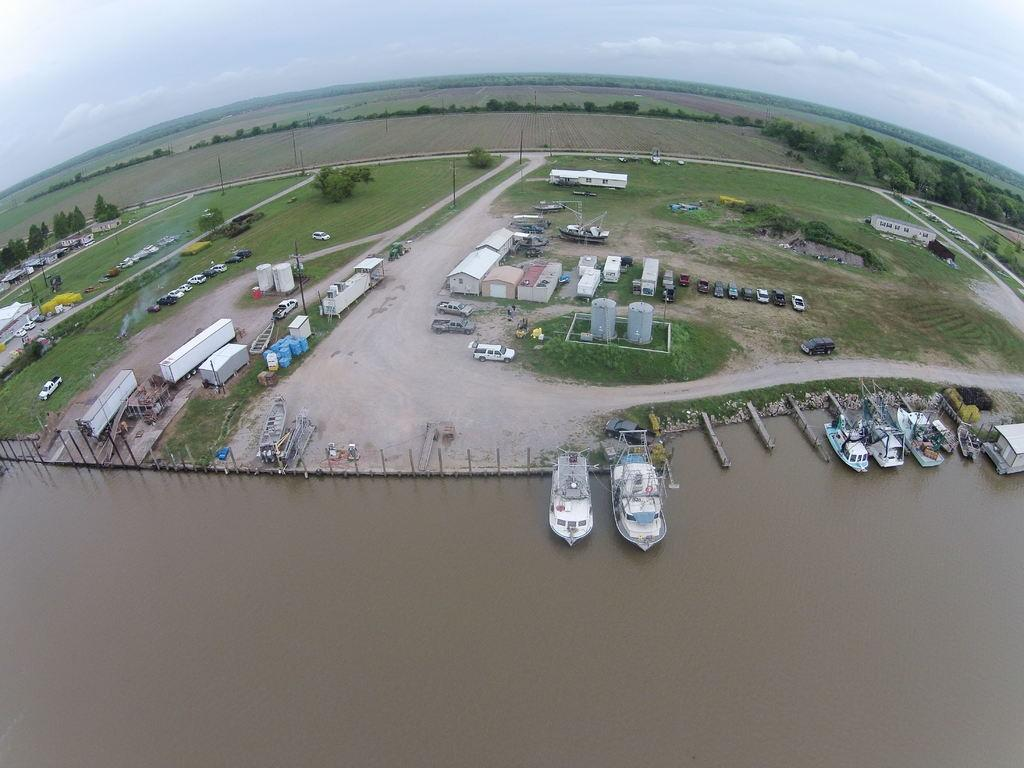What perspective is used to view the scene in the image? The image shows a top view of a place. What types of structures can be seen in the image? There are buildings and houses in the image. What natural elements are visible in the image? There are plants visible in the image. What mode of transportation can be seen on the water in the image? There are boats on the water in the image. Where is the grandmother sitting in the image? There is no grandmother present in the image. What side of the image are the plants located? The question about the side of the image is not relevant, as the image is a top view and does not have sides. 